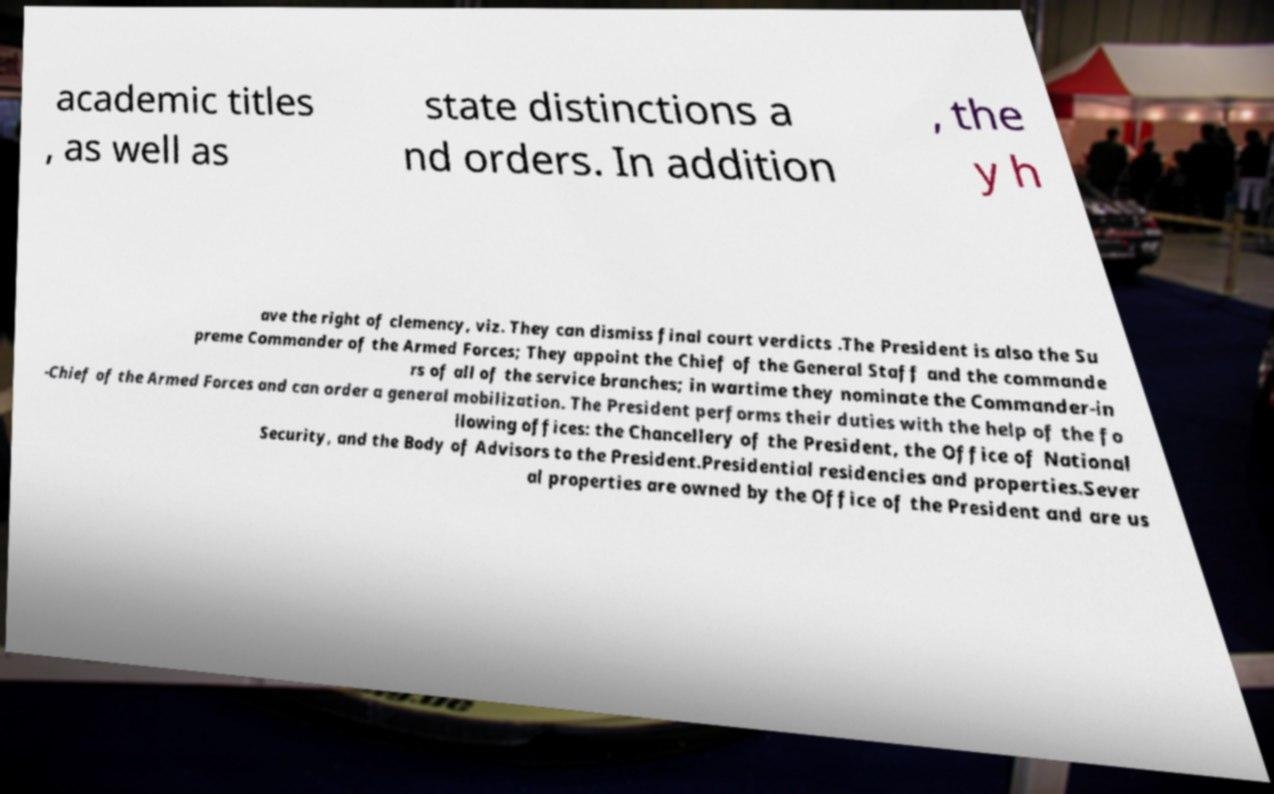Please identify and transcribe the text found in this image. academic titles , as well as state distinctions a nd orders. In addition , the y h ave the right of clemency, viz. They can dismiss final court verdicts .The President is also the Su preme Commander of the Armed Forces; They appoint the Chief of the General Staff and the commande rs of all of the service branches; in wartime they nominate the Commander-in -Chief of the Armed Forces and can order a general mobilization. The President performs their duties with the help of the fo llowing offices: the Chancellery of the President, the Office of National Security, and the Body of Advisors to the President.Presidential residencies and properties.Sever al properties are owned by the Office of the President and are us 